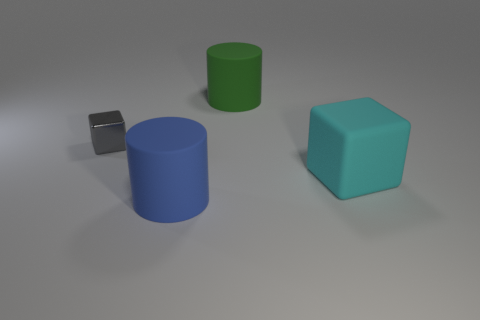What number of things are either large matte cylinders that are in front of the cyan thing or blue matte cylinders?
Make the answer very short. 1. What is the color of the block that is made of the same material as the green cylinder?
Give a very brief answer. Cyan. Are there any other metallic things of the same size as the green thing?
Make the answer very short. No. What number of things are big things in front of the gray block or things on the left side of the blue thing?
Give a very brief answer. 3. What shape is the blue thing that is the same size as the green rubber cylinder?
Your answer should be very brief. Cylinder. Is there another matte thing of the same shape as the blue object?
Make the answer very short. Yes. Are there fewer matte objects than cyan things?
Offer a terse response. No. There is a block that is right of the small gray object; is its size the same as the shiny object that is on the left side of the large green matte thing?
Ensure brevity in your answer.  No. How many objects are either blue shiny objects or metallic things?
Your answer should be very brief. 1. There is a cylinder that is right of the large blue matte cylinder; what is its size?
Ensure brevity in your answer.  Large. 